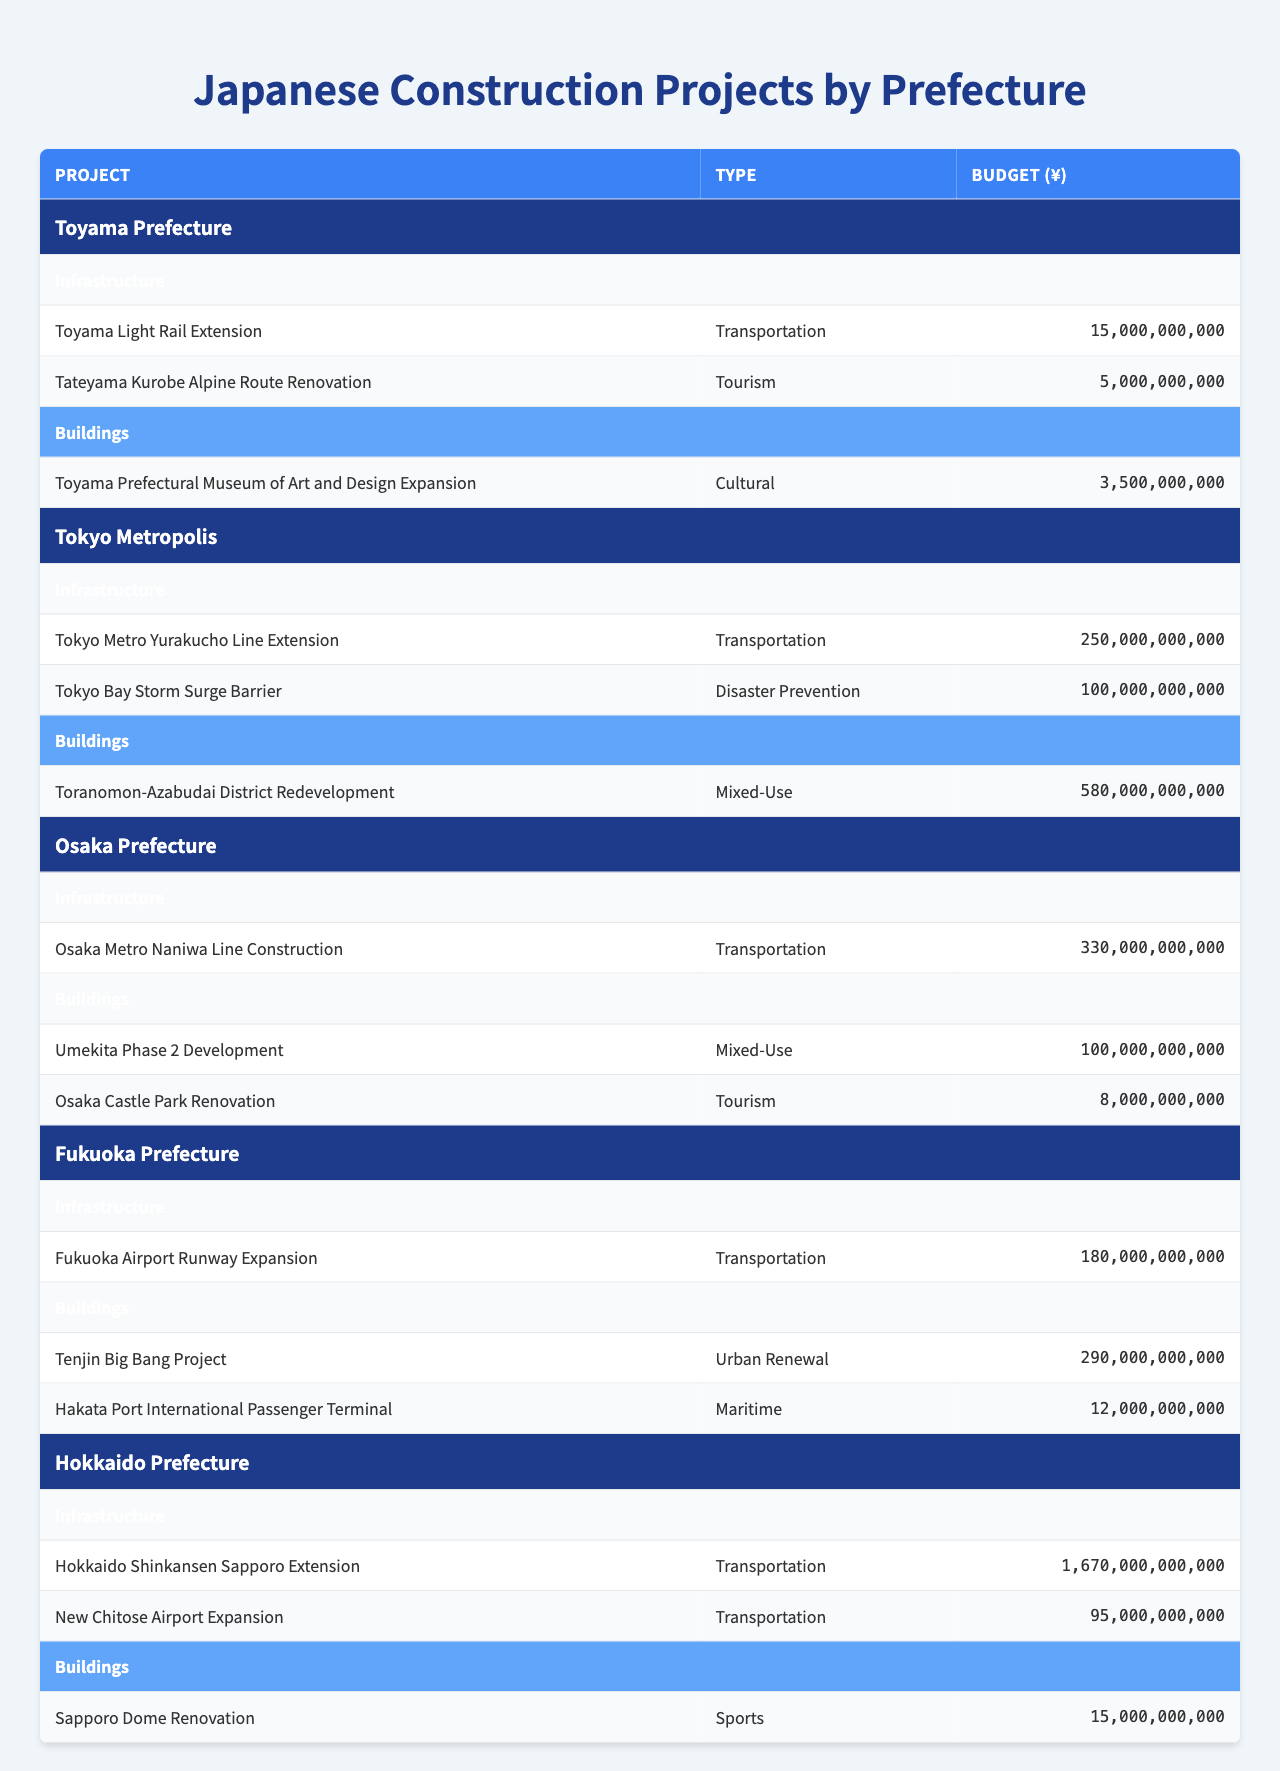What is the total budget for construction projects in Toyama Prefecture? The total budget for Toyama Prefecture is calculated by adding the budgets of all projects listed for both Infrastructure and Buildings: 15,000,000,000 + 5,000,000,000 + 3,500,000,000 = 23,500,000,000.
Answer: 23,500,000,000 Which prefecture has the highest budget for a single infrastructure project? By looking at the Infrastructure section for each prefecture, Hokkaido Prefecture's project "Hokkaido Shinkansen Sapporo Extension" has the highest budget of 1,670,000,000,000.
Answer: Hokkaido Prefecture How many projects are under the “Buildings” category in Fukuoka Prefecture? In Fukuoka Prefecture's Buildings section, there are two projects listed: "Tenjin Big Bang Project" and "Hakata Port International Passenger Terminal."
Answer: 2 What is the average budget for building projects across all prefectures? The total budget for building projects is calculated by summing up the budgets of all buildings: 3,500,000,000 (Toyama) + 580,000,000,000 (Tokyo) + 100,000,000,000 (Osaka) + 290,000,000,000 (Fukuoka) + 15,000,000,000 (Hokkaido) = 988,500,000,000. There are five projects, so the average is 988,500,000,000 / 5 = 197,700,000,000.
Answer: 197,700,000,000 Which type of project in Osaka Prefecture has the smallest budget? In the Buildings section, the project with the smallest budget is "Osaka Castle Park Renovation" with a budget of 8,000,000,000, compared to "Umekita Phase 2 Development" and "Osaka Metro Naniwa Line Construction" in the Infrastructure section.
Answer: 8,000,000,000 Is there a tourism-related project in Hokkaido Prefecture? Hokkaido Prefecture has one project listed under Buildings, which is "Sapporo Dome Renovation," a sports-related project, and no tourism-related project is specifically mentioned. Therefore, the answer is no.
Answer: No What is the difference in budget between the most expensive and least expensive infrastructure projects in Tokyo Metropolis? The most expensive project is "Tokyo Metro Yurakucho Line Extension" at 250,000,000,000, and the least expensive is "Tokyo Bay Storm Surge Barrier," at 100,000,000,000. The difference is calculated as 250,000,000,000 - 100,000,000,000 = 150,000,000,000.
Answer: 150,000,000,000 How many different types of projects are listed for Fukuoka Prefecture? Fukuoka Prefecture has three different types of projects: Transportation (Infrastructure), Urban Renewal (Buildings), and Maritime (Buildings). Thus, there are three types listed.
Answer: 3 